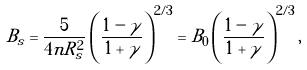<formula> <loc_0><loc_0><loc_500><loc_500>B _ { s } = \frac { 5 } { 4 n R _ { s } ^ { 2 } } \left ( \frac { 1 - \gamma } { 1 + \gamma } \right ) ^ { 2 / 3 } = B _ { 0 } \left ( \frac { 1 - \gamma } { 1 + \gamma } \right ) ^ { 2 / 3 } ,</formula> 